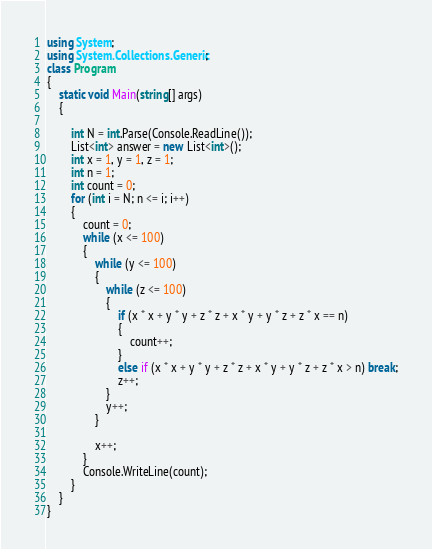<code> <loc_0><loc_0><loc_500><loc_500><_C#_>using System;
using System.Collections.Generic;
class Program
{
    static void Main(string[] args)
    {

        int N = int.Parse(Console.ReadLine());
        List<int> answer = new List<int>();
        int x = 1, y = 1, z = 1;
        int n = 1;
        int count = 0;
        for (int i = N; n <= i; i++)
        {
            count = 0;
            while (x <= 100)
            {
                while (y <= 100)
                {
                    while (z <= 100)
                    {
                        if (x * x + y * y + z * z + x * y + y * z + z * x == n)
                        {
                            count++;
                        }
                        else if (x * x + y * y + z * z + x * y + y * z + z * x > n) break;
                        z++;
                    }
                    y++;
                }

                x++;
            }
            Console.WriteLine(count);
        }
    }
}
</code> 